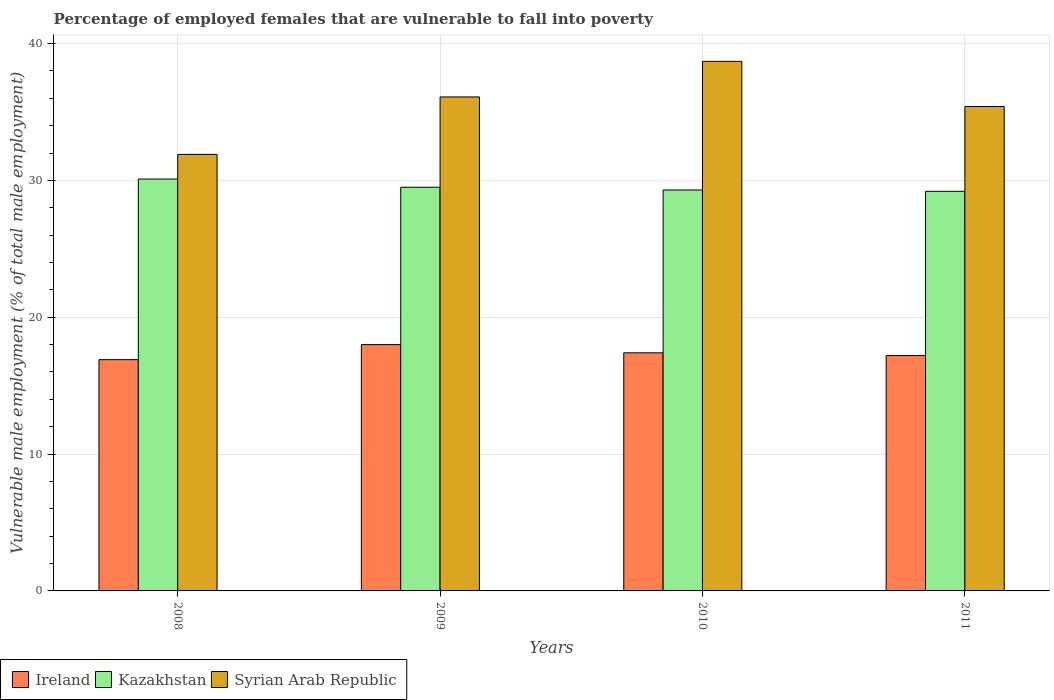How many groups of bars are there?
Provide a short and direct response. 4. Are the number of bars per tick equal to the number of legend labels?
Keep it short and to the point. Yes. Are the number of bars on each tick of the X-axis equal?
Your response must be concise. Yes. What is the percentage of employed females who are vulnerable to fall into poverty in Syrian Arab Republic in 2010?
Ensure brevity in your answer.  38.7. Across all years, what is the maximum percentage of employed females who are vulnerable to fall into poverty in Syrian Arab Republic?
Offer a very short reply. 38.7. Across all years, what is the minimum percentage of employed females who are vulnerable to fall into poverty in Ireland?
Provide a short and direct response. 16.9. In which year was the percentage of employed females who are vulnerable to fall into poverty in Kazakhstan maximum?
Your response must be concise. 2008. In which year was the percentage of employed females who are vulnerable to fall into poverty in Kazakhstan minimum?
Your response must be concise. 2011. What is the total percentage of employed females who are vulnerable to fall into poverty in Ireland in the graph?
Your response must be concise. 69.5. What is the difference between the percentage of employed females who are vulnerable to fall into poverty in Kazakhstan in 2009 and that in 2011?
Make the answer very short. 0.3. What is the difference between the percentage of employed females who are vulnerable to fall into poverty in Kazakhstan in 2011 and the percentage of employed females who are vulnerable to fall into poverty in Syrian Arab Republic in 2010?
Make the answer very short. -9.5. What is the average percentage of employed females who are vulnerable to fall into poverty in Kazakhstan per year?
Provide a short and direct response. 29.53. In the year 2011, what is the difference between the percentage of employed females who are vulnerable to fall into poverty in Ireland and percentage of employed females who are vulnerable to fall into poverty in Syrian Arab Republic?
Provide a short and direct response. -18.2. What is the ratio of the percentage of employed females who are vulnerable to fall into poverty in Syrian Arab Republic in 2009 to that in 2011?
Your answer should be very brief. 1.02. Is the percentage of employed females who are vulnerable to fall into poverty in Kazakhstan in 2010 less than that in 2011?
Your response must be concise. No. Is the difference between the percentage of employed females who are vulnerable to fall into poverty in Ireland in 2009 and 2011 greater than the difference between the percentage of employed females who are vulnerable to fall into poverty in Syrian Arab Republic in 2009 and 2011?
Keep it short and to the point. Yes. What is the difference between the highest and the second highest percentage of employed females who are vulnerable to fall into poverty in Syrian Arab Republic?
Your answer should be compact. 2.6. What is the difference between the highest and the lowest percentage of employed females who are vulnerable to fall into poverty in Kazakhstan?
Ensure brevity in your answer.  0.9. Is the sum of the percentage of employed females who are vulnerable to fall into poverty in Kazakhstan in 2008 and 2010 greater than the maximum percentage of employed females who are vulnerable to fall into poverty in Ireland across all years?
Offer a terse response. Yes. What does the 1st bar from the left in 2008 represents?
Offer a very short reply. Ireland. What does the 1st bar from the right in 2011 represents?
Provide a short and direct response. Syrian Arab Republic. Is it the case that in every year, the sum of the percentage of employed females who are vulnerable to fall into poverty in Ireland and percentage of employed females who are vulnerable to fall into poverty in Kazakhstan is greater than the percentage of employed females who are vulnerable to fall into poverty in Syrian Arab Republic?
Make the answer very short. Yes. How many bars are there?
Your answer should be compact. 12. How many legend labels are there?
Your response must be concise. 3. What is the title of the graph?
Ensure brevity in your answer.  Percentage of employed females that are vulnerable to fall into poverty. What is the label or title of the Y-axis?
Make the answer very short. Vulnerable male employment (% of total male employment). What is the Vulnerable male employment (% of total male employment) in Ireland in 2008?
Make the answer very short. 16.9. What is the Vulnerable male employment (% of total male employment) in Kazakhstan in 2008?
Provide a succinct answer. 30.1. What is the Vulnerable male employment (% of total male employment) in Syrian Arab Republic in 2008?
Your response must be concise. 31.9. What is the Vulnerable male employment (% of total male employment) in Ireland in 2009?
Make the answer very short. 18. What is the Vulnerable male employment (% of total male employment) of Kazakhstan in 2009?
Offer a terse response. 29.5. What is the Vulnerable male employment (% of total male employment) of Syrian Arab Republic in 2009?
Your answer should be very brief. 36.1. What is the Vulnerable male employment (% of total male employment) in Ireland in 2010?
Keep it short and to the point. 17.4. What is the Vulnerable male employment (% of total male employment) in Kazakhstan in 2010?
Provide a succinct answer. 29.3. What is the Vulnerable male employment (% of total male employment) in Syrian Arab Republic in 2010?
Provide a succinct answer. 38.7. What is the Vulnerable male employment (% of total male employment) in Ireland in 2011?
Give a very brief answer. 17.2. What is the Vulnerable male employment (% of total male employment) in Kazakhstan in 2011?
Offer a very short reply. 29.2. What is the Vulnerable male employment (% of total male employment) of Syrian Arab Republic in 2011?
Give a very brief answer. 35.4. Across all years, what is the maximum Vulnerable male employment (% of total male employment) in Kazakhstan?
Make the answer very short. 30.1. Across all years, what is the maximum Vulnerable male employment (% of total male employment) in Syrian Arab Republic?
Your answer should be very brief. 38.7. Across all years, what is the minimum Vulnerable male employment (% of total male employment) of Ireland?
Provide a short and direct response. 16.9. Across all years, what is the minimum Vulnerable male employment (% of total male employment) in Kazakhstan?
Provide a short and direct response. 29.2. Across all years, what is the minimum Vulnerable male employment (% of total male employment) of Syrian Arab Republic?
Your response must be concise. 31.9. What is the total Vulnerable male employment (% of total male employment) of Ireland in the graph?
Keep it short and to the point. 69.5. What is the total Vulnerable male employment (% of total male employment) in Kazakhstan in the graph?
Ensure brevity in your answer.  118.1. What is the total Vulnerable male employment (% of total male employment) of Syrian Arab Republic in the graph?
Make the answer very short. 142.1. What is the difference between the Vulnerable male employment (% of total male employment) in Syrian Arab Republic in 2008 and that in 2009?
Make the answer very short. -4.2. What is the difference between the Vulnerable male employment (% of total male employment) of Ireland in 2009 and that in 2010?
Make the answer very short. 0.6. What is the difference between the Vulnerable male employment (% of total male employment) of Kazakhstan in 2009 and that in 2010?
Offer a very short reply. 0.2. What is the difference between the Vulnerable male employment (% of total male employment) of Kazakhstan in 2010 and that in 2011?
Keep it short and to the point. 0.1. What is the difference between the Vulnerable male employment (% of total male employment) of Syrian Arab Republic in 2010 and that in 2011?
Your answer should be compact. 3.3. What is the difference between the Vulnerable male employment (% of total male employment) of Ireland in 2008 and the Vulnerable male employment (% of total male employment) of Syrian Arab Republic in 2009?
Provide a short and direct response. -19.2. What is the difference between the Vulnerable male employment (% of total male employment) in Ireland in 2008 and the Vulnerable male employment (% of total male employment) in Kazakhstan in 2010?
Provide a succinct answer. -12.4. What is the difference between the Vulnerable male employment (% of total male employment) in Ireland in 2008 and the Vulnerable male employment (% of total male employment) in Syrian Arab Republic in 2010?
Your response must be concise. -21.8. What is the difference between the Vulnerable male employment (% of total male employment) of Ireland in 2008 and the Vulnerable male employment (% of total male employment) of Syrian Arab Republic in 2011?
Give a very brief answer. -18.5. What is the difference between the Vulnerable male employment (% of total male employment) of Ireland in 2009 and the Vulnerable male employment (% of total male employment) of Kazakhstan in 2010?
Your answer should be compact. -11.3. What is the difference between the Vulnerable male employment (% of total male employment) in Ireland in 2009 and the Vulnerable male employment (% of total male employment) in Syrian Arab Republic in 2010?
Your response must be concise. -20.7. What is the difference between the Vulnerable male employment (% of total male employment) of Kazakhstan in 2009 and the Vulnerable male employment (% of total male employment) of Syrian Arab Republic in 2010?
Offer a terse response. -9.2. What is the difference between the Vulnerable male employment (% of total male employment) in Ireland in 2009 and the Vulnerable male employment (% of total male employment) in Syrian Arab Republic in 2011?
Offer a terse response. -17.4. What is the average Vulnerable male employment (% of total male employment) in Ireland per year?
Provide a short and direct response. 17.38. What is the average Vulnerable male employment (% of total male employment) in Kazakhstan per year?
Provide a succinct answer. 29.52. What is the average Vulnerable male employment (% of total male employment) in Syrian Arab Republic per year?
Provide a short and direct response. 35.52. In the year 2008, what is the difference between the Vulnerable male employment (% of total male employment) in Kazakhstan and Vulnerable male employment (% of total male employment) in Syrian Arab Republic?
Provide a short and direct response. -1.8. In the year 2009, what is the difference between the Vulnerable male employment (% of total male employment) of Ireland and Vulnerable male employment (% of total male employment) of Kazakhstan?
Make the answer very short. -11.5. In the year 2009, what is the difference between the Vulnerable male employment (% of total male employment) of Ireland and Vulnerable male employment (% of total male employment) of Syrian Arab Republic?
Keep it short and to the point. -18.1. In the year 2010, what is the difference between the Vulnerable male employment (% of total male employment) in Ireland and Vulnerable male employment (% of total male employment) in Syrian Arab Republic?
Offer a terse response. -21.3. In the year 2011, what is the difference between the Vulnerable male employment (% of total male employment) in Ireland and Vulnerable male employment (% of total male employment) in Syrian Arab Republic?
Give a very brief answer. -18.2. What is the ratio of the Vulnerable male employment (% of total male employment) in Ireland in 2008 to that in 2009?
Your answer should be compact. 0.94. What is the ratio of the Vulnerable male employment (% of total male employment) of Kazakhstan in 2008 to that in 2009?
Your answer should be compact. 1.02. What is the ratio of the Vulnerable male employment (% of total male employment) in Syrian Arab Republic in 2008 to that in 2009?
Make the answer very short. 0.88. What is the ratio of the Vulnerable male employment (% of total male employment) of Ireland in 2008 to that in 2010?
Your response must be concise. 0.97. What is the ratio of the Vulnerable male employment (% of total male employment) in Kazakhstan in 2008 to that in 2010?
Your answer should be very brief. 1.03. What is the ratio of the Vulnerable male employment (% of total male employment) of Syrian Arab Republic in 2008 to that in 2010?
Offer a terse response. 0.82. What is the ratio of the Vulnerable male employment (% of total male employment) of Ireland in 2008 to that in 2011?
Give a very brief answer. 0.98. What is the ratio of the Vulnerable male employment (% of total male employment) in Kazakhstan in 2008 to that in 2011?
Offer a terse response. 1.03. What is the ratio of the Vulnerable male employment (% of total male employment) in Syrian Arab Republic in 2008 to that in 2011?
Make the answer very short. 0.9. What is the ratio of the Vulnerable male employment (% of total male employment) in Ireland in 2009 to that in 2010?
Offer a terse response. 1.03. What is the ratio of the Vulnerable male employment (% of total male employment) in Kazakhstan in 2009 to that in 2010?
Your answer should be compact. 1.01. What is the ratio of the Vulnerable male employment (% of total male employment) of Syrian Arab Republic in 2009 to that in 2010?
Offer a very short reply. 0.93. What is the ratio of the Vulnerable male employment (% of total male employment) in Ireland in 2009 to that in 2011?
Make the answer very short. 1.05. What is the ratio of the Vulnerable male employment (% of total male employment) in Kazakhstan in 2009 to that in 2011?
Provide a succinct answer. 1.01. What is the ratio of the Vulnerable male employment (% of total male employment) in Syrian Arab Republic in 2009 to that in 2011?
Offer a terse response. 1.02. What is the ratio of the Vulnerable male employment (% of total male employment) of Ireland in 2010 to that in 2011?
Provide a succinct answer. 1.01. What is the ratio of the Vulnerable male employment (% of total male employment) in Kazakhstan in 2010 to that in 2011?
Ensure brevity in your answer.  1. What is the ratio of the Vulnerable male employment (% of total male employment) in Syrian Arab Republic in 2010 to that in 2011?
Give a very brief answer. 1.09. What is the difference between the highest and the second highest Vulnerable male employment (% of total male employment) of Syrian Arab Republic?
Provide a succinct answer. 2.6. What is the difference between the highest and the lowest Vulnerable male employment (% of total male employment) of Ireland?
Offer a very short reply. 1.1. What is the difference between the highest and the lowest Vulnerable male employment (% of total male employment) of Kazakhstan?
Your answer should be very brief. 0.9. What is the difference between the highest and the lowest Vulnerable male employment (% of total male employment) in Syrian Arab Republic?
Your response must be concise. 6.8. 